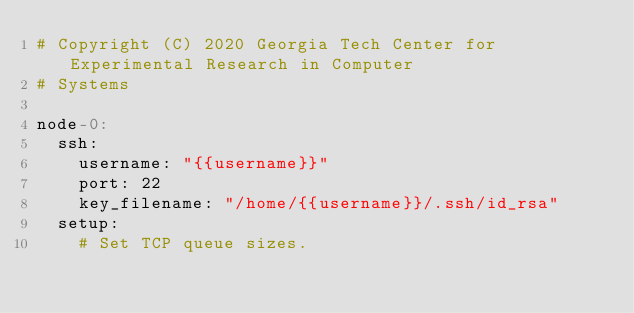<code> <loc_0><loc_0><loc_500><loc_500><_YAML_># Copyright (C) 2020 Georgia Tech Center for Experimental Research in Computer
# Systems

node-0:
  ssh:
    username: "{{username}}"
    port: 22
    key_filename: "/home/{{username}}/.ssh/id_rsa"
  setup:
    # Set TCP queue sizes.</code> 